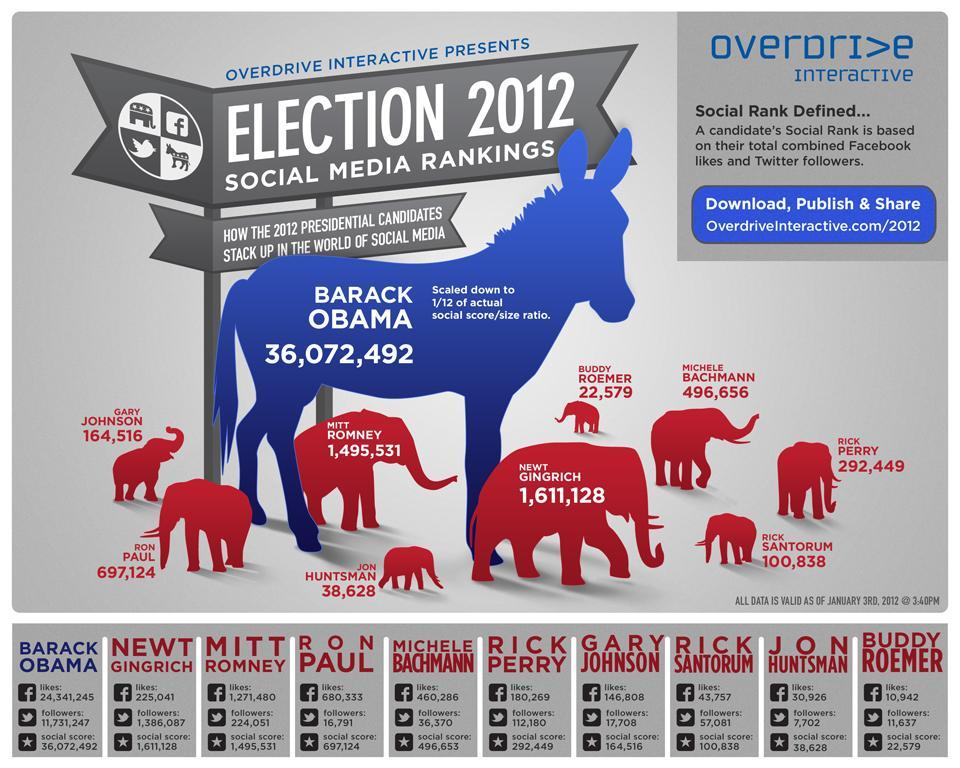Who has the highest social score in the U.S. Election 2012?
Answer the question with a short phrase. BARACK OBAMA What is the number of Facebook likes of Mitt Romney as of January 3, 2012? 1,271,480 How many people follow Barack Obama on twitter as of January 3, 2012? 11,731,247 